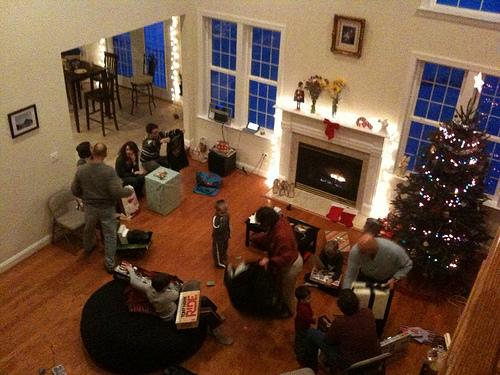What can often be found under the tree seen here? Please explain your reasoning. gifts. Gifts are traditionally found under christmas trees such as this. 